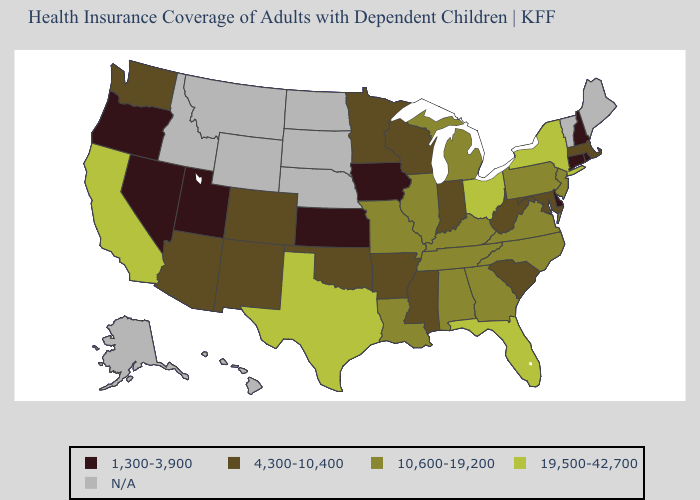What is the value of Florida?
Keep it brief. 19,500-42,700. Name the states that have a value in the range 1,300-3,900?
Give a very brief answer. Connecticut, Delaware, Iowa, Kansas, Nevada, New Hampshire, Oregon, Rhode Island, Utah. What is the value of Michigan?
Write a very short answer. 10,600-19,200. Among the states that border Tennessee , does Arkansas have the lowest value?
Give a very brief answer. Yes. Name the states that have a value in the range 1,300-3,900?
Be succinct. Connecticut, Delaware, Iowa, Kansas, Nevada, New Hampshire, Oregon, Rhode Island, Utah. What is the value of Alabama?
Write a very short answer. 10,600-19,200. What is the value of South Carolina?
Concise answer only. 4,300-10,400. What is the value of Rhode Island?
Keep it brief. 1,300-3,900. What is the value of Connecticut?
Answer briefly. 1,300-3,900. Does the map have missing data?
Keep it brief. Yes. What is the value of West Virginia?
Short answer required. 4,300-10,400. Name the states that have a value in the range 1,300-3,900?
Write a very short answer. Connecticut, Delaware, Iowa, Kansas, Nevada, New Hampshire, Oregon, Rhode Island, Utah. What is the value of Virginia?
Answer briefly. 10,600-19,200. Among the states that border West Virginia , which have the highest value?
Concise answer only. Ohio. 